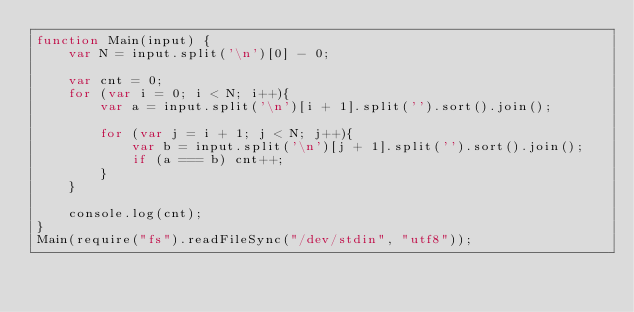<code> <loc_0><loc_0><loc_500><loc_500><_JavaScript_>function Main(input) {
    var N = input.split('\n')[0] - 0;

    var cnt = 0;
    for (var i = 0; i < N; i++){
        var a = input.split('\n')[i + 1].split('').sort().join();

        for (var j = i + 1; j < N; j++){
            var b = input.split('\n')[j + 1].split('').sort().join();
            if (a === b) cnt++;
        }
    }

    console.log(cnt);
}
Main(require("fs").readFileSync("/dev/stdin", "utf8"));</code> 